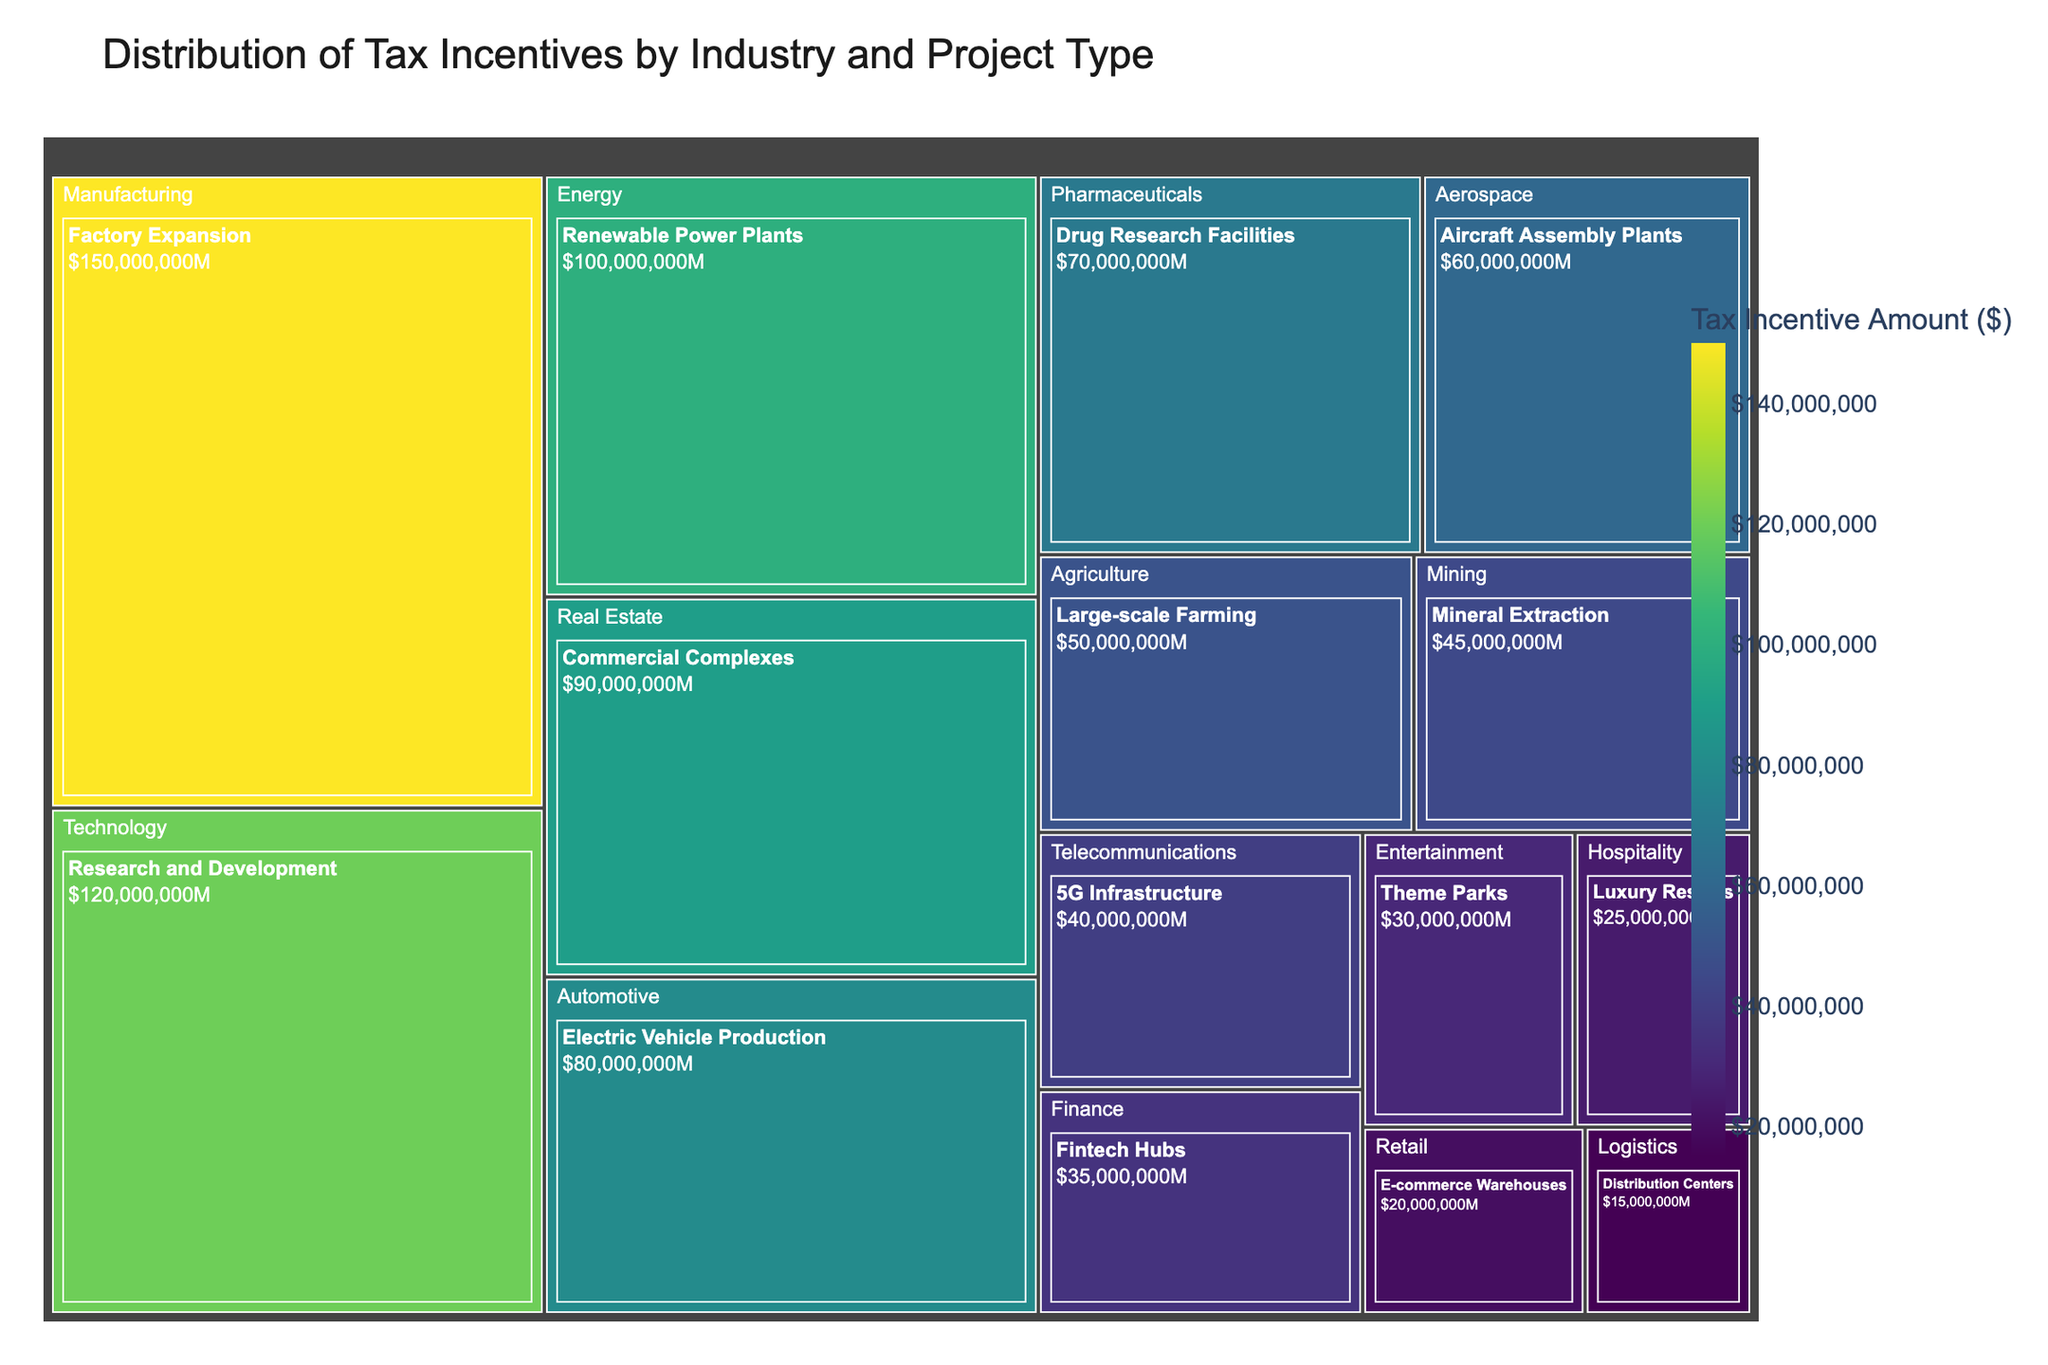What's the largest tax incentive amount granted according to the treemap? The largest tax incentive can be found by identifying the largest block in the treemap. The block with "Manufacturing - Factory Expansion" is the biggest, showing a tax incentive amount of $150,000,000.
Answer: $150,000,000 Which industry received the least tax incentives? The industry with the smallest block represents the least tax incentives. "Logistics - Distribution Centers" is the smallest block, indicating an amount of $15,000,000.
Answer: Logistics How much more tax incentive did Manufacturing receive compared to Energy? Find the blocks for Manufacturing and Energy. Manufacturing received $150,000,000 and Energy received $100,000,000. The difference is $150,000,000 - $100,000,000 = $50,000,000.
Answer: $50,000,000 What is the combined tax incentive amount for the Technology and Pharmaceutical industries? Find the blocks for Technology and Pharmaceuticals. Technology received $120,000,000, and Pharmaceuticals received $70,000,000. Sum them up: $120,000,000 + $70,000,000 = $190,000,000.
Answer: $190,000,000 Which project type in the Automotive industry received tax incentives and how much? In the treemap, the Automotive industry block shows "Electric Vehicle Production" as the project type, which received $80,000,000.
Answer: Electric Vehicle Production, $80,000,000 Between Real Estate and Telecommunications, which industry received a higher amount of tax incentives and by how much? Compare the tax incentive amounts from the treemap: Real Estate received $90,000,000 and Telecommunications received $40,000,000. The difference is $90,000,000 - $40,000,000 = $50,000,000.
Answer: Real Estate, $50,000,000 What are the top three industries receiving the highest tax incentives? Identify the three largest blocks from the treemap: Manufacturing ($150,000,000), Technology ($120,000,000), and Energy ($100,000,000).
Answer: Manufacturing, Technology, Energy Calculate the total tax incentives granted to all industries combined. Sum the tax incentive amounts for all blocks in the treemap: $150,000,000 + $120,000,000 + $100,000,000 + $90,000,000 + $80,000,000 + $70,000,000 + $60,000,000 + $50,000,000 + $45,000,000 + $40,000,000 + $35,000,000 + $30,000,000 + $25,000,000 + $20,000,000 + $15,000,000 = $925,000,000.
Answer: $925,000,000 How does the tax incentive amount for Mining compare to Agriculture? Find the amounts for Mining ($45,000,000) and Agriculture ($50,000,000). Mining received $5,000,000 less than Agriculture.
Answer: $5,000,000 less What project type in the Finance industry received a tax incentive and how much was it? The Finance industry block in the treemap shows "Fintech Hubs" as the project type with a tax incentive amount of $35,000,000.
Answer: Fintech Hubs, $35,000,000 